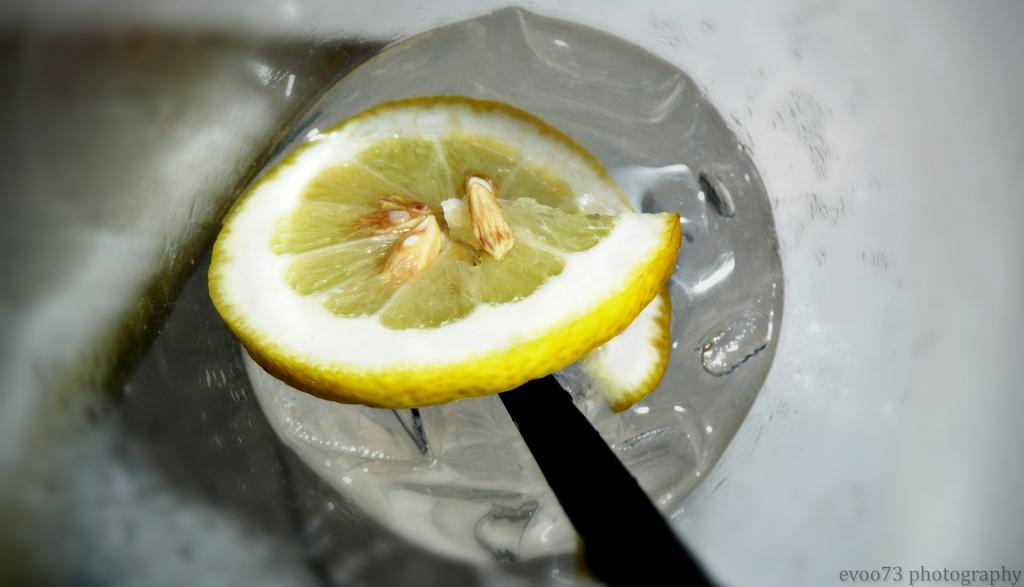What type of fruit is represented in the image? There is a piece of lemon in the image. What can be seen inside the lemon? There are seeds visible in the image. Where is the text located in the image? The text is at the right bottom of the image. What type of finger can be seen reacting to the lemon in the image? There are no fingers or reactions present in the image; it only shows a piece of lemon and seeds. 